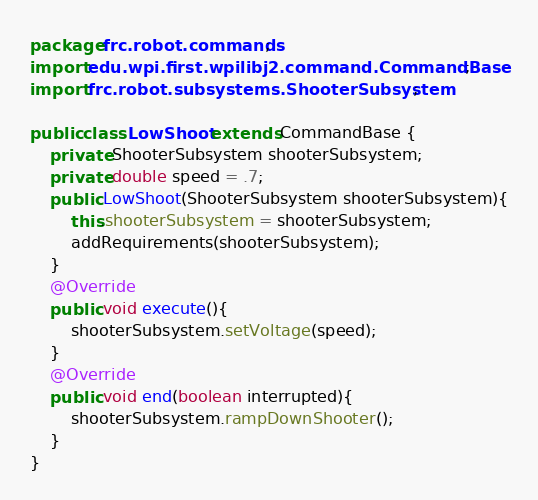<code> <loc_0><loc_0><loc_500><loc_500><_Java_>package frc.robot.commands;
import edu.wpi.first.wpilibj2.command.CommandBase;
import frc.robot.subsystems.ShooterSubsystem;

public class LowShoot extends CommandBase {
    private ShooterSubsystem shooterSubsystem;
    private double speed = .7;
    public LowShoot(ShooterSubsystem shooterSubsystem){
        this.shooterSubsystem = shooterSubsystem;
        addRequirements(shooterSubsystem);
    }
    @Override
    public void execute(){
        shooterSubsystem.setVoltage(speed);
    }
    @Override
    public void end(boolean interrupted){
        shooterSubsystem.rampDownShooter();
    }
}
</code> 